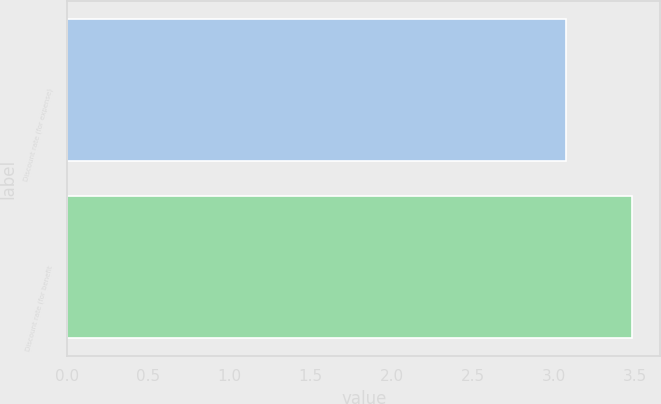Convert chart. <chart><loc_0><loc_0><loc_500><loc_500><bar_chart><fcel>Discount rate (for expense)<fcel>Discount rate (for benefit<nl><fcel>3.07<fcel>3.48<nl></chart> 